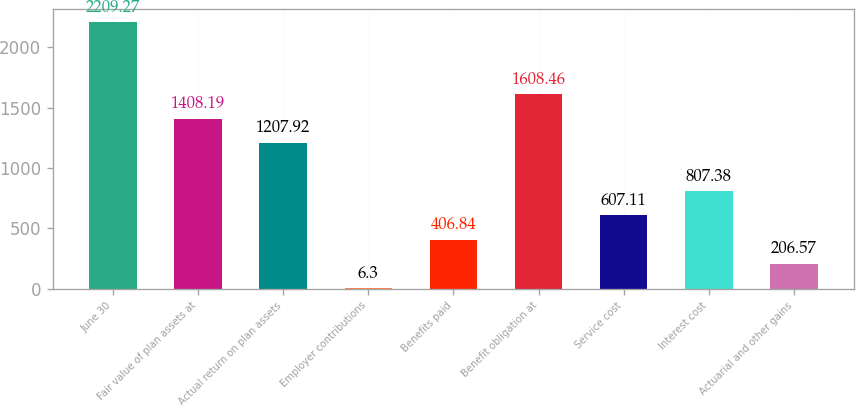Convert chart to OTSL. <chart><loc_0><loc_0><loc_500><loc_500><bar_chart><fcel>June 30<fcel>Fair value of plan assets at<fcel>Actual return on plan assets<fcel>Employer contributions<fcel>Benefits paid<fcel>Benefit obligation at<fcel>Service cost<fcel>Interest cost<fcel>Actuarial and other gains<nl><fcel>2209.27<fcel>1408.19<fcel>1207.92<fcel>6.3<fcel>406.84<fcel>1608.46<fcel>607.11<fcel>807.38<fcel>206.57<nl></chart> 